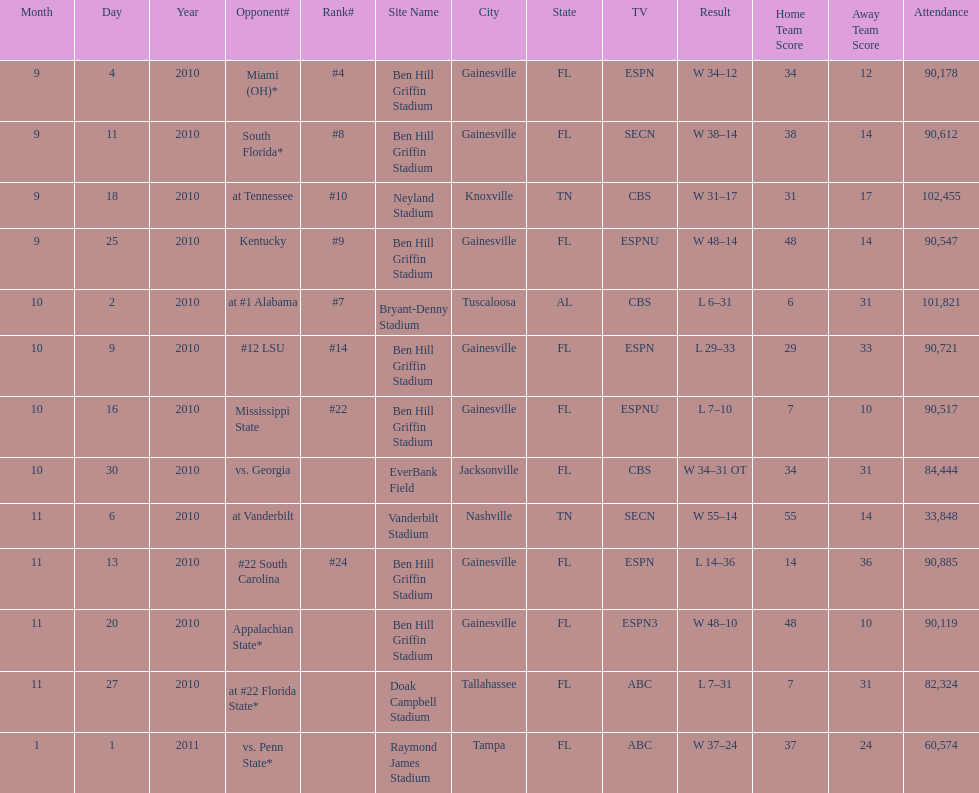What is the number of games played in teh 2010-2011 season 13. 